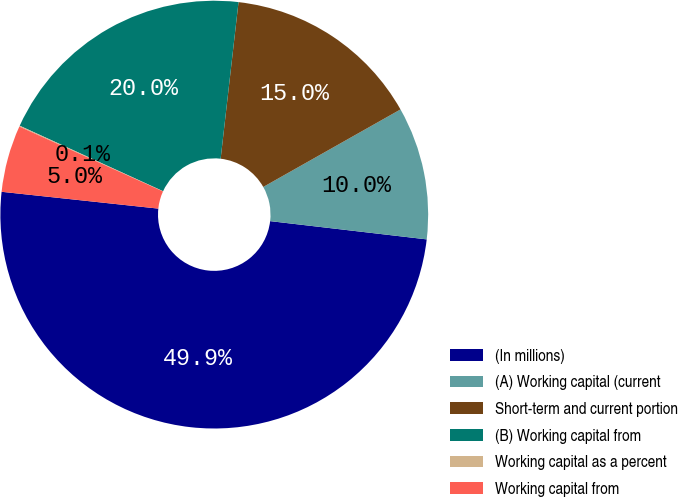Convert chart. <chart><loc_0><loc_0><loc_500><loc_500><pie_chart><fcel>(In millions)<fcel>(A) Working capital (current<fcel>Short-term and current portion<fcel>(B) Working capital from<fcel>Working capital as a percent<fcel>Working capital from<nl><fcel>49.86%<fcel>10.03%<fcel>15.01%<fcel>19.99%<fcel>0.07%<fcel>5.05%<nl></chart> 